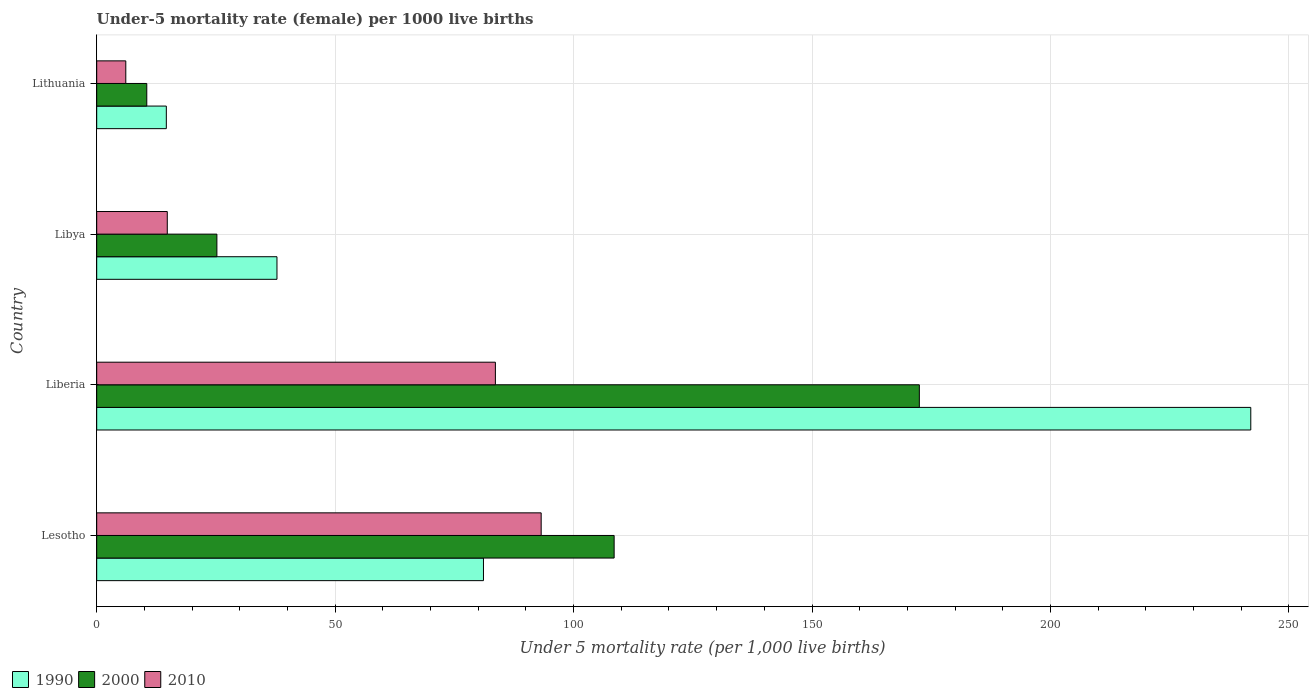How many groups of bars are there?
Ensure brevity in your answer.  4. Are the number of bars per tick equal to the number of legend labels?
Offer a very short reply. Yes. What is the label of the 2nd group of bars from the top?
Give a very brief answer. Libya. Across all countries, what is the maximum under-five mortality rate in 2000?
Offer a very short reply. 172.5. Across all countries, what is the minimum under-five mortality rate in 1990?
Provide a succinct answer. 14.6. In which country was the under-five mortality rate in 2010 maximum?
Keep it short and to the point. Lesotho. In which country was the under-five mortality rate in 2000 minimum?
Give a very brief answer. Lithuania. What is the total under-five mortality rate in 1990 in the graph?
Offer a terse response. 375.5. What is the difference between the under-five mortality rate in 1990 in Lesotho and that in Lithuania?
Offer a very short reply. 66.5. What is the difference between the under-five mortality rate in 2010 in Lesotho and the under-five mortality rate in 1990 in Liberia?
Offer a very short reply. -148.8. What is the average under-five mortality rate in 2010 per country?
Your answer should be compact. 49.43. What is the difference between the under-five mortality rate in 2000 and under-five mortality rate in 2010 in Lesotho?
Provide a succinct answer. 15.3. What is the ratio of the under-five mortality rate in 2010 in Liberia to that in Libya?
Provide a short and direct response. 5.65. Is the under-five mortality rate in 1990 in Liberia less than that in Lithuania?
Your answer should be compact. No. What is the difference between the highest and the second highest under-five mortality rate in 1990?
Your answer should be compact. 160.9. What is the difference between the highest and the lowest under-five mortality rate in 1990?
Keep it short and to the point. 227.4. In how many countries, is the under-five mortality rate in 2010 greater than the average under-five mortality rate in 2010 taken over all countries?
Keep it short and to the point. 2. Is the sum of the under-five mortality rate in 2000 in Lesotho and Libya greater than the maximum under-five mortality rate in 1990 across all countries?
Provide a succinct answer. No. What does the 3rd bar from the top in Lesotho represents?
Provide a succinct answer. 1990. What does the 2nd bar from the bottom in Lithuania represents?
Give a very brief answer. 2000. Is it the case that in every country, the sum of the under-five mortality rate in 2000 and under-five mortality rate in 1990 is greater than the under-five mortality rate in 2010?
Offer a very short reply. Yes. Are all the bars in the graph horizontal?
Your answer should be compact. Yes. How many countries are there in the graph?
Offer a very short reply. 4. What is the difference between two consecutive major ticks on the X-axis?
Your answer should be compact. 50. Does the graph contain any zero values?
Offer a terse response. No. Does the graph contain grids?
Offer a very short reply. Yes. How are the legend labels stacked?
Provide a short and direct response. Horizontal. What is the title of the graph?
Your answer should be compact. Under-5 mortality rate (female) per 1000 live births. What is the label or title of the X-axis?
Offer a very short reply. Under 5 mortality rate (per 1,0 live births). What is the Under 5 mortality rate (per 1,000 live births) in 1990 in Lesotho?
Provide a short and direct response. 81.1. What is the Under 5 mortality rate (per 1,000 live births) of 2000 in Lesotho?
Keep it short and to the point. 108.5. What is the Under 5 mortality rate (per 1,000 live births) in 2010 in Lesotho?
Your answer should be compact. 93.2. What is the Under 5 mortality rate (per 1,000 live births) in 1990 in Liberia?
Your answer should be very brief. 242. What is the Under 5 mortality rate (per 1,000 live births) of 2000 in Liberia?
Your response must be concise. 172.5. What is the Under 5 mortality rate (per 1,000 live births) in 2010 in Liberia?
Your answer should be compact. 83.6. What is the Under 5 mortality rate (per 1,000 live births) of 1990 in Libya?
Offer a terse response. 37.8. What is the Under 5 mortality rate (per 1,000 live births) of 2000 in Libya?
Give a very brief answer. 25.2. What is the Under 5 mortality rate (per 1,000 live births) in 2000 in Lithuania?
Give a very brief answer. 10.5. Across all countries, what is the maximum Under 5 mortality rate (per 1,000 live births) of 1990?
Provide a short and direct response. 242. Across all countries, what is the maximum Under 5 mortality rate (per 1,000 live births) of 2000?
Your answer should be compact. 172.5. Across all countries, what is the maximum Under 5 mortality rate (per 1,000 live births) in 2010?
Offer a very short reply. 93.2. What is the total Under 5 mortality rate (per 1,000 live births) of 1990 in the graph?
Offer a terse response. 375.5. What is the total Under 5 mortality rate (per 1,000 live births) of 2000 in the graph?
Ensure brevity in your answer.  316.7. What is the total Under 5 mortality rate (per 1,000 live births) in 2010 in the graph?
Give a very brief answer. 197.7. What is the difference between the Under 5 mortality rate (per 1,000 live births) in 1990 in Lesotho and that in Liberia?
Make the answer very short. -160.9. What is the difference between the Under 5 mortality rate (per 1,000 live births) of 2000 in Lesotho and that in Liberia?
Your answer should be compact. -64. What is the difference between the Under 5 mortality rate (per 1,000 live births) of 1990 in Lesotho and that in Libya?
Offer a very short reply. 43.3. What is the difference between the Under 5 mortality rate (per 1,000 live births) in 2000 in Lesotho and that in Libya?
Your answer should be compact. 83.3. What is the difference between the Under 5 mortality rate (per 1,000 live births) of 2010 in Lesotho and that in Libya?
Keep it short and to the point. 78.4. What is the difference between the Under 5 mortality rate (per 1,000 live births) of 1990 in Lesotho and that in Lithuania?
Keep it short and to the point. 66.5. What is the difference between the Under 5 mortality rate (per 1,000 live births) in 2000 in Lesotho and that in Lithuania?
Provide a short and direct response. 98. What is the difference between the Under 5 mortality rate (per 1,000 live births) of 2010 in Lesotho and that in Lithuania?
Your answer should be compact. 87.1. What is the difference between the Under 5 mortality rate (per 1,000 live births) in 1990 in Liberia and that in Libya?
Keep it short and to the point. 204.2. What is the difference between the Under 5 mortality rate (per 1,000 live births) in 2000 in Liberia and that in Libya?
Give a very brief answer. 147.3. What is the difference between the Under 5 mortality rate (per 1,000 live births) of 2010 in Liberia and that in Libya?
Your answer should be very brief. 68.8. What is the difference between the Under 5 mortality rate (per 1,000 live births) in 1990 in Liberia and that in Lithuania?
Keep it short and to the point. 227.4. What is the difference between the Under 5 mortality rate (per 1,000 live births) in 2000 in Liberia and that in Lithuania?
Your answer should be very brief. 162. What is the difference between the Under 5 mortality rate (per 1,000 live births) of 2010 in Liberia and that in Lithuania?
Your answer should be compact. 77.5. What is the difference between the Under 5 mortality rate (per 1,000 live births) of 1990 in Libya and that in Lithuania?
Provide a short and direct response. 23.2. What is the difference between the Under 5 mortality rate (per 1,000 live births) in 2000 in Libya and that in Lithuania?
Your response must be concise. 14.7. What is the difference between the Under 5 mortality rate (per 1,000 live births) of 1990 in Lesotho and the Under 5 mortality rate (per 1,000 live births) of 2000 in Liberia?
Give a very brief answer. -91.4. What is the difference between the Under 5 mortality rate (per 1,000 live births) of 2000 in Lesotho and the Under 5 mortality rate (per 1,000 live births) of 2010 in Liberia?
Your answer should be compact. 24.9. What is the difference between the Under 5 mortality rate (per 1,000 live births) of 1990 in Lesotho and the Under 5 mortality rate (per 1,000 live births) of 2000 in Libya?
Offer a terse response. 55.9. What is the difference between the Under 5 mortality rate (per 1,000 live births) in 1990 in Lesotho and the Under 5 mortality rate (per 1,000 live births) in 2010 in Libya?
Give a very brief answer. 66.3. What is the difference between the Under 5 mortality rate (per 1,000 live births) of 2000 in Lesotho and the Under 5 mortality rate (per 1,000 live births) of 2010 in Libya?
Your response must be concise. 93.7. What is the difference between the Under 5 mortality rate (per 1,000 live births) of 1990 in Lesotho and the Under 5 mortality rate (per 1,000 live births) of 2000 in Lithuania?
Give a very brief answer. 70.6. What is the difference between the Under 5 mortality rate (per 1,000 live births) in 2000 in Lesotho and the Under 5 mortality rate (per 1,000 live births) in 2010 in Lithuania?
Keep it short and to the point. 102.4. What is the difference between the Under 5 mortality rate (per 1,000 live births) in 1990 in Liberia and the Under 5 mortality rate (per 1,000 live births) in 2000 in Libya?
Give a very brief answer. 216.8. What is the difference between the Under 5 mortality rate (per 1,000 live births) of 1990 in Liberia and the Under 5 mortality rate (per 1,000 live births) of 2010 in Libya?
Give a very brief answer. 227.2. What is the difference between the Under 5 mortality rate (per 1,000 live births) of 2000 in Liberia and the Under 5 mortality rate (per 1,000 live births) of 2010 in Libya?
Provide a short and direct response. 157.7. What is the difference between the Under 5 mortality rate (per 1,000 live births) in 1990 in Liberia and the Under 5 mortality rate (per 1,000 live births) in 2000 in Lithuania?
Your response must be concise. 231.5. What is the difference between the Under 5 mortality rate (per 1,000 live births) in 1990 in Liberia and the Under 5 mortality rate (per 1,000 live births) in 2010 in Lithuania?
Offer a very short reply. 235.9. What is the difference between the Under 5 mortality rate (per 1,000 live births) of 2000 in Liberia and the Under 5 mortality rate (per 1,000 live births) of 2010 in Lithuania?
Offer a very short reply. 166.4. What is the difference between the Under 5 mortality rate (per 1,000 live births) of 1990 in Libya and the Under 5 mortality rate (per 1,000 live births) of 2000 in Lithuania?
Your answer should be compact. 27.3. What is the difference between the Under 5 mortality rate (per 1,000 live births) of 1990 in Libya and the Under 5 mortality rate (per 1,000 live births) of 2010 in Lithuania?
Ensure brevity in your answer.  31.7. What is the average Under 5 mortality rate (per 1,000 live births) in 1990 per country?
Ensure brevity in your answer.  93.88. What is the average Under 5 mortality rate (per 1,000 live births) in 2000 per country?
Your answer should be very brief. 79.17. What is the average Under 5 mortality rate (per 1,000 live births) of 2010 per country?
Ensure brevity in your answer.  49.42. What is the difference between the Under 5 mortality rate (per 1,000 live births) in 1990 and Under 5 mortality rate (per 1,000 live births) in 2000 in Lesotho?
Make the answer very short. -27.4. What is the difference between the Under 5 mortality rate (per 1,000 live births) of 1990 and Under 5 mortality rate (per 1,000 live births) of 2010 in Lesotho?
Provide a short and direct response. -12.1. What is the difference between the Under 5 mortality rate (per 1,000 live births) in 1990 and Under 5 mortality rate (per 1,000 live births) in 2000 in Liberia?
Make the answer very short. 69.5. What is the difference between the Under 5 mortality rate (per 1,000 live births) of 1990 and Under 5 mortality rate (per 1,000 live births) of 2010 in Liberia?
Ensure brevity in your answer.  158.4. What is the difference between the Under 5 mortality rate (per 1,000 live births) of 2000 and Under 5 mortality rate (per 1,000 live births) of 2010 in Liberia?
Your response must be concise. 88.9. What is the difference between the Under 5 mortality rate (per 1,000 live births) of 1990 and Under 5 mortality rate (per 1,000 live births) of 2000 in Libya?
Provide a succinct answer. 12.6. What is the difference between the Under 5 mortality rate (per 1,000 live births) of 1990 and Under 5 mortality rate (per 1,000 live births) of 2010 in Libya?
Provide a succinct answer. 23. What is the difference between the Under 5 mortality rate (per 1,000 live births) in 2000 and Under 5 mortality rate (per 1,000 live births) in 2010 in Libya?
Your answer should be compact. 10.4. What is the difference between the Under 5 mortality rate (per 1,000 live births) in 1990 and Under 5 mortality rate (per 1,000 live births) in 2000 in Lithuania?
Offer a terse response. 4.1. What is the ratio of the Under 5 mortality rate (per 1,000 live births) of 1990 in Lesotho to that in Liberia?
Ensure brevity in your answer.  0.34. What is the ratio of the Under 5 mortality rate (per 1,000 live births) in 2000 in Lesotho to that in Liberia?
Provide a succinct answer. 0.63. What is the ratio of the Under 5 mortality rate (per 1,000 live births) in 2010 in Lesotho to that in Liberia?
Keep it short and to the point. 1.11. What is the ratio of the Under 5 mortality rate (per 1,000 live births) of 1990 in Lesotho to that in Libya?
Give a very brief answer. 2.15. What is the ratio of the Under 5 mortality rate (per 1,000 live births) of 2000 in Lesotho to that in Libya?
Your answer should be very brief. 4.31. What is the ratio of the Under 5 mortality rate (per 1,000 live births) in 2010 in Lesotho to that in Libya?
Ensure brevity in your answer.  6.3. What is the ratio of the Under 5 mortality rate (per 1,000 live births) of 1990 in Lesotho to that in Lithuania?
Make the answer very short. 5.55. What is the ratio of the Under 5 mortality rate (per 1,000 live births) in 2000 in Lesotho to that in Lithuania?
Your response must be concise. 10.33. What is the ratio of the Under 5 mortality rate (per 1,000 live births) in 2010 in Lesotho to that in Lithuania?
Make the answer very short. 15.28. What is the ratio of the Under 5 mortality rate (per 1,000 live births) in 1990 in Liberia to that in Libya?
Provide a short and direct response. 6.4. What is the ratio of the Under 5 mortality rate (per 1,000 live births) in 2000 in Liberia to that in Libya?
Your answer should be very brief. 6.85. What is the ratio of the Under 5 mortality rate (per 1,000 live births) in 2010 in Liberia to that in Libya?
Your answer should be compact. 5.65. What is the ratio of the Under 5 mortality rate (per 1,000 live births) of 1990 in Liberia to that in Lithuania?
Ensure brevity in your answer.  16.58. What is the ratio of the Under 5 mortality rate (per 1,000 live births) in 2000 in Liberia to that in Lithuania?
Keep it short and to the point. 16.43. What is the ratio of the Under 5 mortality rate (per 1,000 live births) of 2010 in Liberia to that in Lithuania?
Ensure brevity in your answer.  13.7. What is the ratio of the Under 5 mortality rate (per 1,000 live births) of 1990 in Libya to that in Lithuania?
Keep it short and to the point. 2.59. What is the ratio of the Under 5 mortality rate (per 1,000 live births) in 2000 in Libya to that in Lithuania?
Your answer should be very brief. 2.4. What is the ratio of the Under 5 mortality rate (per 1,000 live births) in 2010 in Libya to that in Lithuania?
Provide a short and direct response. 2.43. What is the difference between the highest and the second highest Under 5 mortality rate (per 1,000 live births) of 1990?
Your response must be concise. 160.9. What is the difference between the highest and the second highest Under 5 mortality rate (per 1,000 live births) of 2000?
Give a very brief answer. 64. What is the difference between the highest and the second highest Under 5 mortality rate (per 1,000 live births) in 2010?
Your answer should be compact. 9.6. What is the difference between the highest and the lowest Under 5 mortality rate (per 1,000 live births) in 1990?
Make the answer very short. 227.4. What is the difference between the highest and the lowest Under 5 mortality rate (per 1,000 live births) of 2000?
Your answer should be very brief. 162. What is the difference between the highest and the lowest Under 5 mortality rate (per 1,000 live births) of 2010?
Provide a short and direct response. 87.1. 